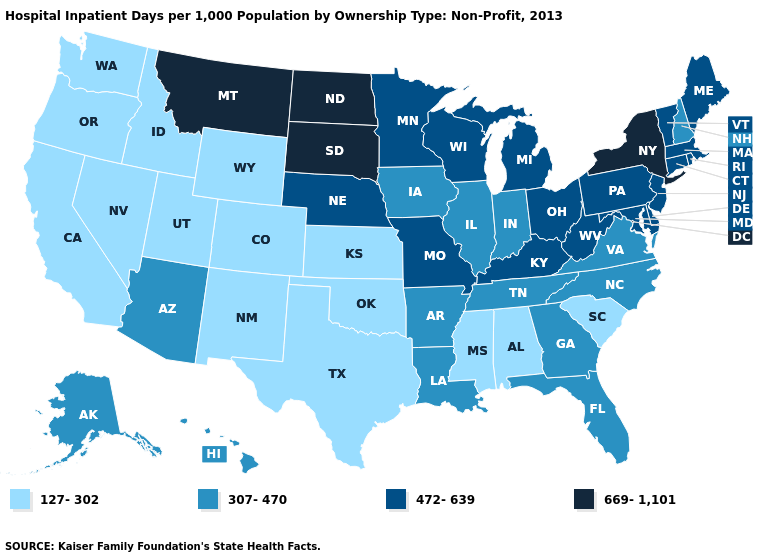What is the lowest value in states that border Minnesota?
Short answer required. 307-470. Which states have the highest value in the USA?
Keep it brief. Montana, New York, North Dakota, South Dakota. What is the value of Louisiana?
Keep it brief. 307-470. Name the states that have a value in the range 472-639?
Quick response, please. Connecticut, Delaware, Kentucky, Maine, Maryland, Massachusetts, Michigan, Minnesota, Missouri, Nebraska, New Jersey, Ohio, Pennsylvania, Rhode Island, Vermont, West Virginia, Wisconsin. What is the lowest value in the USA?
Quick response, please. 127-302. Does Virginia have the same value as Arkansas?
Give a very brief answer. Yes. Name the states that have a value in the range 472-639?
Be succinct. Connecticut, Delaware, Kentucky, Maine, Maryland, Massachusetts, Michigan, Minnesota, Missouri, Nebraska, New Jersey, Ohio, Pennsylvania, Rhode Island, Vermont, West Virginia, Wisconsin. Name the states that have a value in the range 669-1,101?
Keep it brief. Montana, New York, North Dakota, South Dakota. Name the states that have a value in the range 307-470?
Answer briefly. Alaska, Arizona, Arkansas, Florida, Georgia, Hawaii, Illinois, Indiana, Iowa, Louisiana, New Hampshire, North Carolina, Tennessee, Virginia. Among the states that border Connecticut , which have the lowest value?
Keep it brief. Massachusetts, Rhode Island. Among the states that border New Hampshire , which have the highest value?
Concise answer only. Maine, Massachusetts, Vermont. What is the highest value in the Northeast ?
Short answer required. 669-1,101. Which states have the lowest value in the USA?
Give a very brief answer. Alabama, California, Colorado, Idaho, Kansas, Mississippi, Nevada, New Mexico, Oklahoma, Oregon, South Carolina, Texas, Utah, Washington, Wyoming. Name the states that have a value in the range 307-470?
Answer briefly. Alaska, Arizona, Arkansas, Florida, Georgia, Hawaii, Illinois, Indiana, Iowa, Louisiana, New Hampshire, North Carolina, Tennessee, Virginia. Does the first symbol in the legend represent the smallest category?
Give a very brief answer. Yes. 